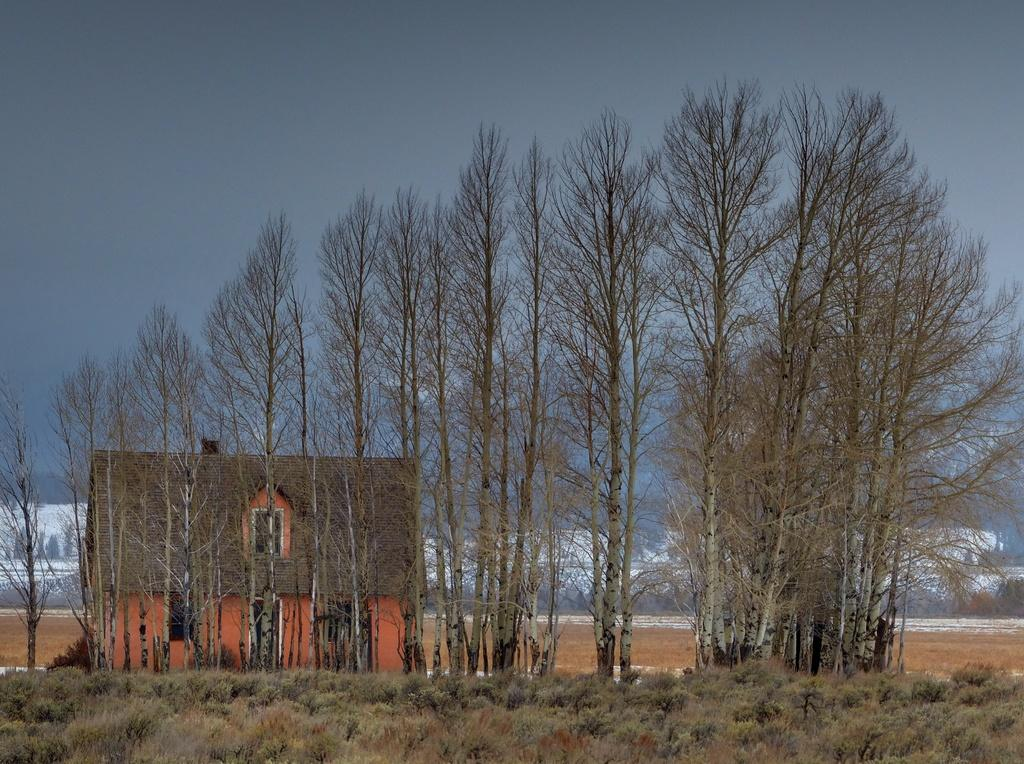What type of structure is located on the left side of the image? There is a house on the left side of the image. What is the color of the house? The house is orange in color. What can be seen in the image besides the house? There are very big trees in the image. What is the condition of the sky in the image? The sky is cloudy in the image. Can you tell me how many boards are used to construct the house in the image? There is no information about the construction of the house in the image, so it is impossible to determine the number of boards used. What type of shock can be seen affecting the trees in the image? There is no shock or any indication of a shock affecting the trees in the image. 